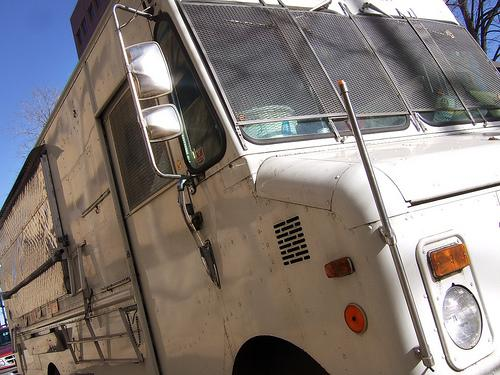Question: what is the photo of?
Choices:
A. Truck.
B. Car.
C. Plane.
D. Boat.
Answer with the letter. Answer: A Question: how many wheels are visible?
Choices:
A. 0.
B. 1.
C. 2.
D. 3.
Answer with the letter. Answer: A Question: how many mirrors are visible?
Choices:
A. 3.
B. 4.
C. 1.
D. 2.
Answer with the letter. Answer: D Question: what color is the turn signal on the front?
Choices:
A. Orange.
B. Red.
C. Green.
D. Yellow.
Answer with the letter. Answer: A Question: what kind of truck is this?
Choices:
A. Gas truck.
B. Semi truck.
C. Food truck.
D. Pickup truck.
Answer with the letter. Answer: C 